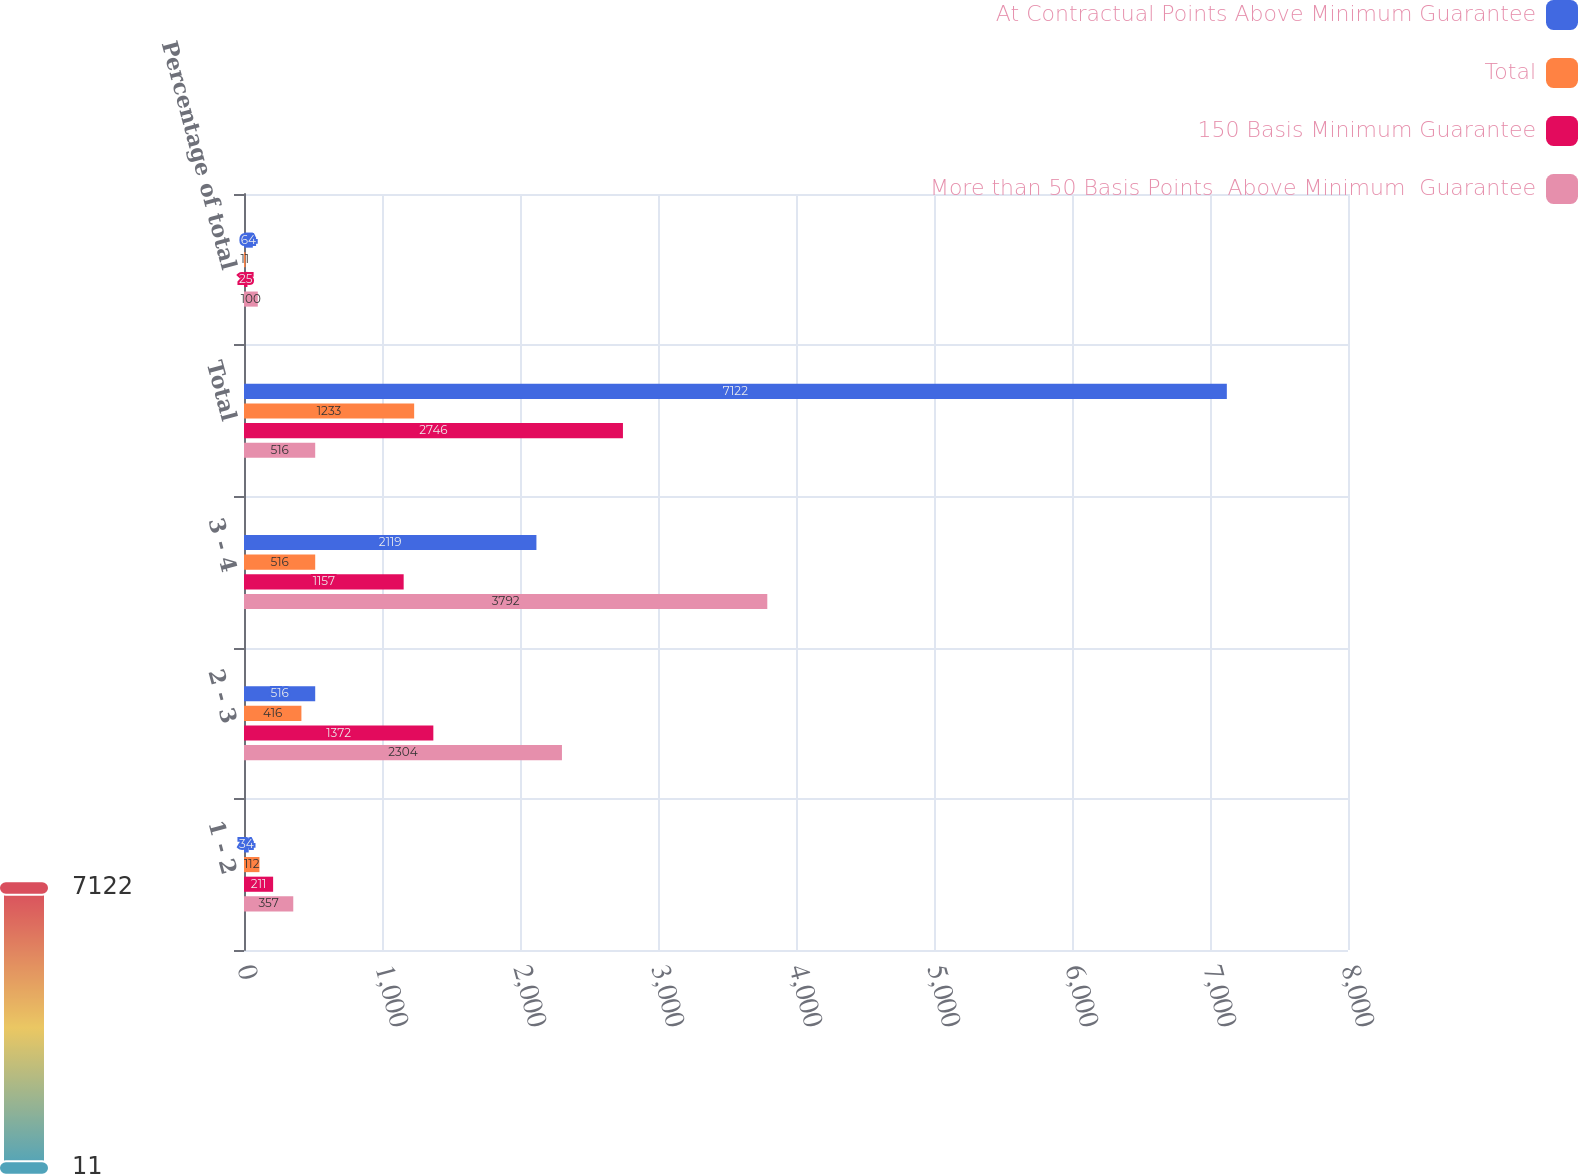<chart> <loc_0><loc_0><loc_500><loc_500><stacked_bar_chart><ecel><fcel>1 - 2<fcel>2 - 3<fcel>3 - 4<fcel>Total<fcel>Percentage of total<nl><fcel>At Contractual Points Above Minimum Guarantee<fcel>34<fcel>516<fcel>2119<fcel>7122<fcel>64<nl><fcel>Total<fcel>112<fcel>416<fcel>516<fcel>1233<fcel>11<nl><fcel>150 Basis Minimum Guarantee<fcel>211<fcel>1372<fcel>1157<fcel>2746<fcel>25<nl><fcel>More than 50 Basis Points  Above Minimum  Guarantee<fcel>357<fcel>2304<fcel>3792<fcel>516<fcel>100<nl></chart> 